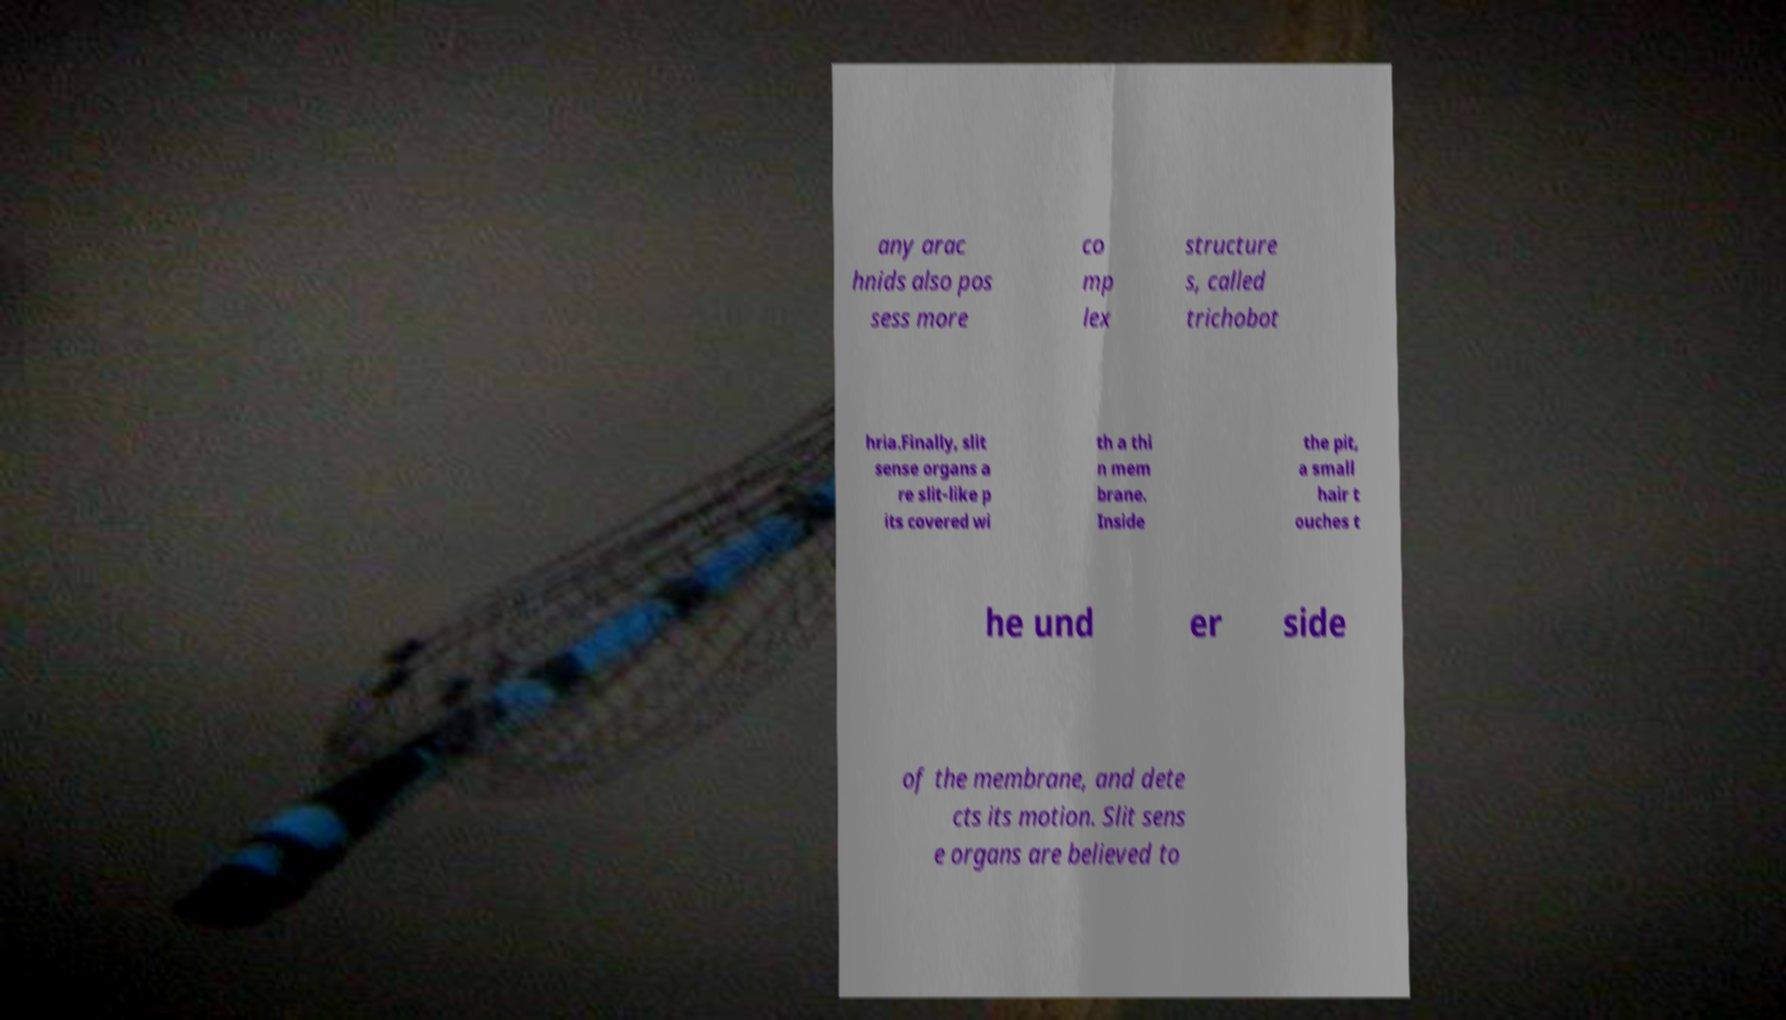Can you accurately transcribe the text from the provided image for me? any arac hnids also pos sess more co mp lex structure s, called trichobot hria.Finally, slit sense organs a re slit-like p its covered wi th a thi n mem brane. Inside the pit, a small hair t ouches t he und er side of the membrane, and dete cts its motion. Slit sens e organs are believed to 